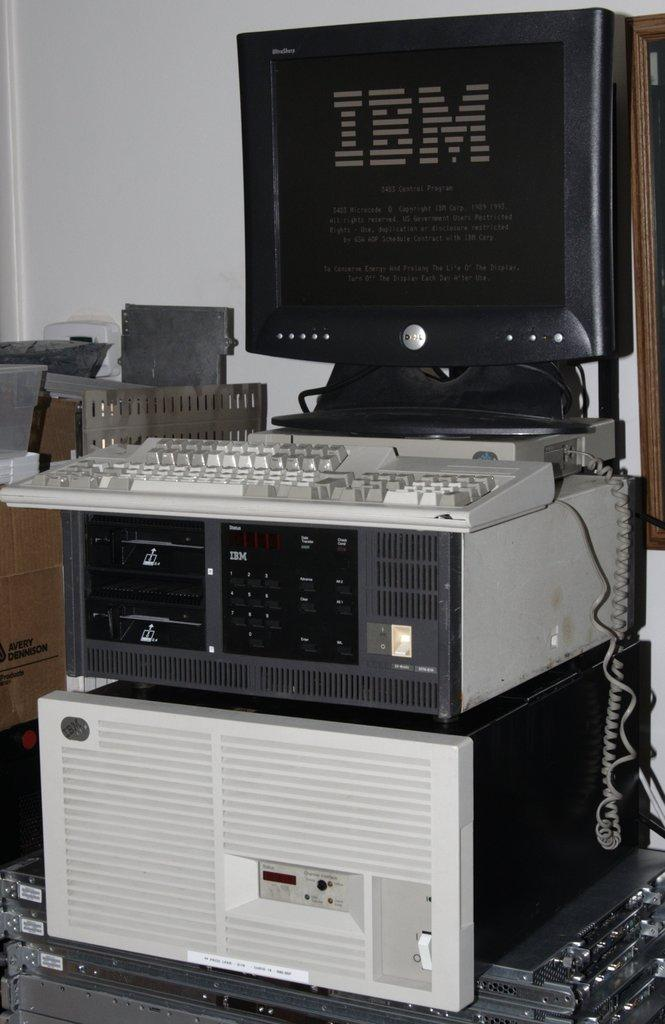<image>
Describe the image concisely. An IBM computer monitor sits atop various computer parts. 